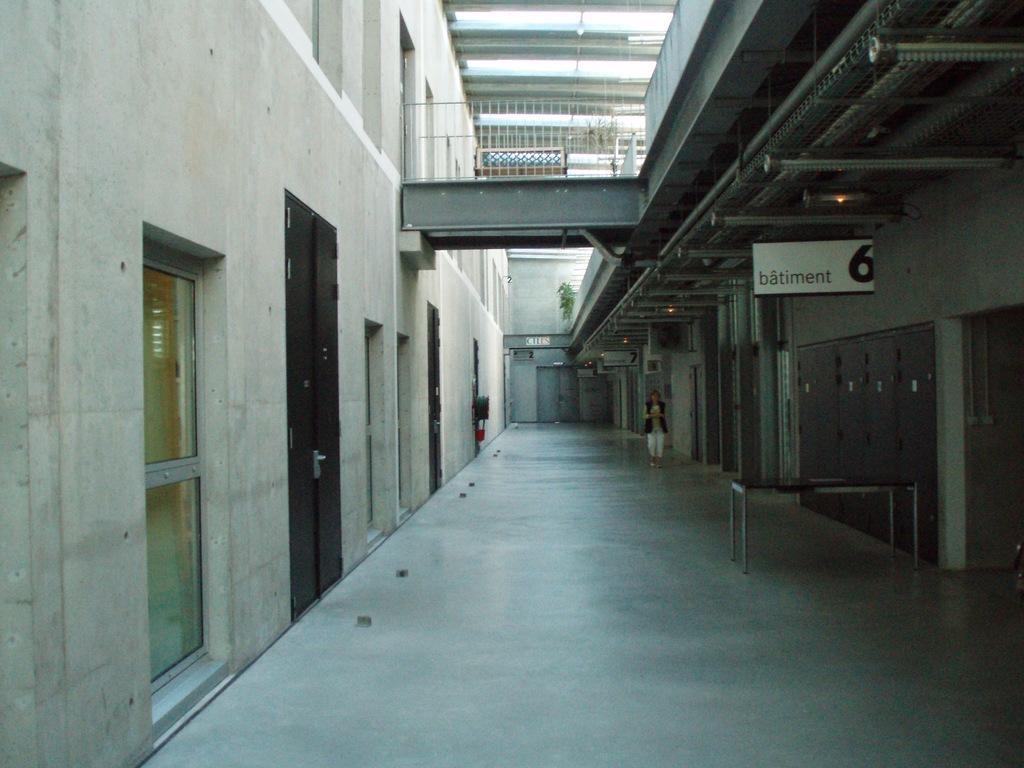In one or two sentences, can you explain what this image depicts? This image is taken indoors. At the bottom of the message there is a floor. In the middle of the image a woman is walking on the floor. There is a board with a text on it. There is a bridge and there are a few railings. At the top of the image there is a ceiling with a few lights. On the left and right sides of the image there are two buildings with walls, windows and doors. There is a table on the floor. 